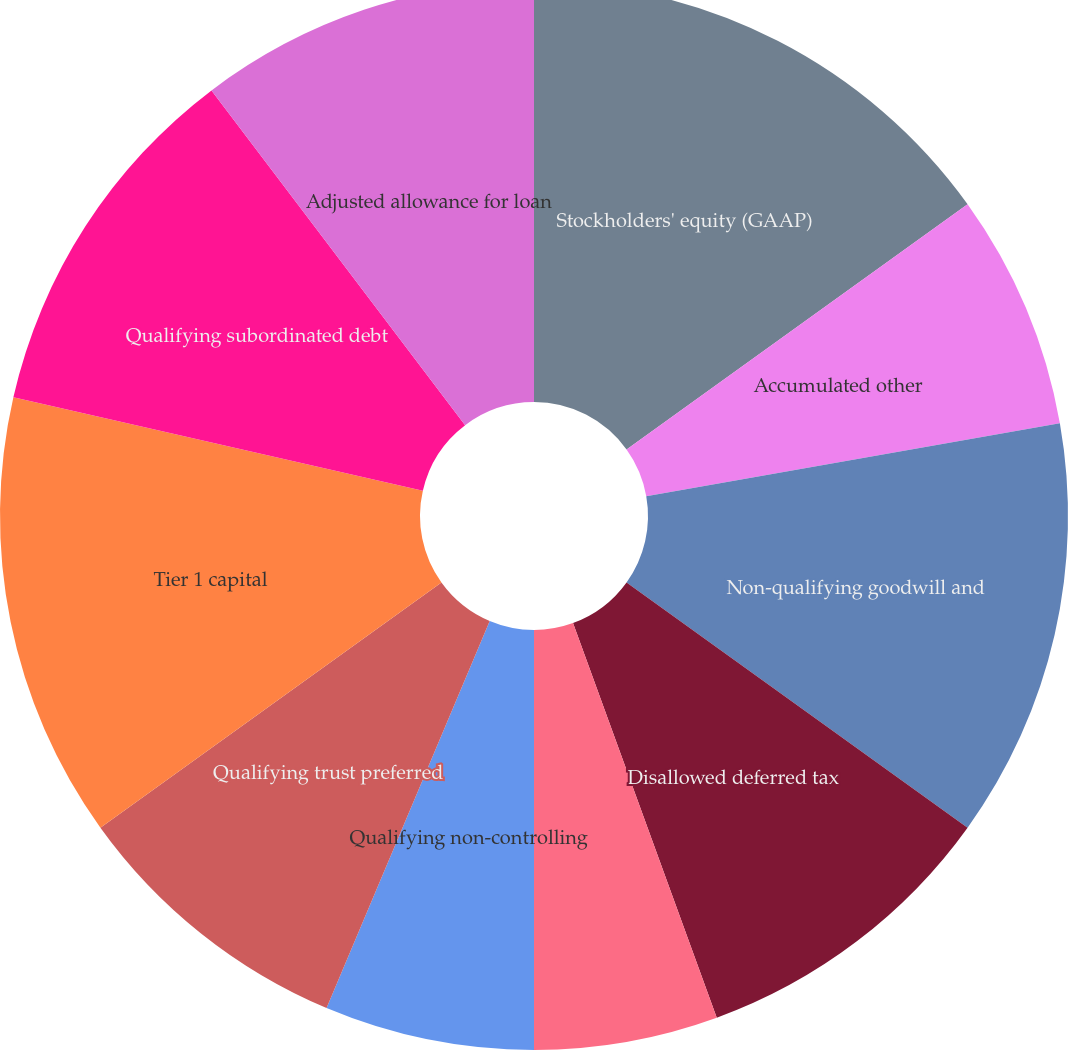<chart> <loc_0><loc_0><loc_500><loc_500><pie_chart><fcel>Stockholders' equity (GAAP)<fcel>Accumulated other<fcel>Non-qualifying goodwill and<fcel>Disallowed deferred tax<fcel>Disallowed servicing assets<fcel>Qualifying non-controlling<fcel>Qualifying trust preferred<fcel>Tier 1 capital<fcel>Qualifying subordinated debt<fcel>Adjusted allowance for loan<nl><fcel>15.08%<fcel>7.14%<fcel>12.7%<fcel>9.52%<fcel>5.56%<fcel>6.35%<fcel>8.73%<fcel>13.49%<fcel>11.11%<fcel>10.32%<nl></chart> 